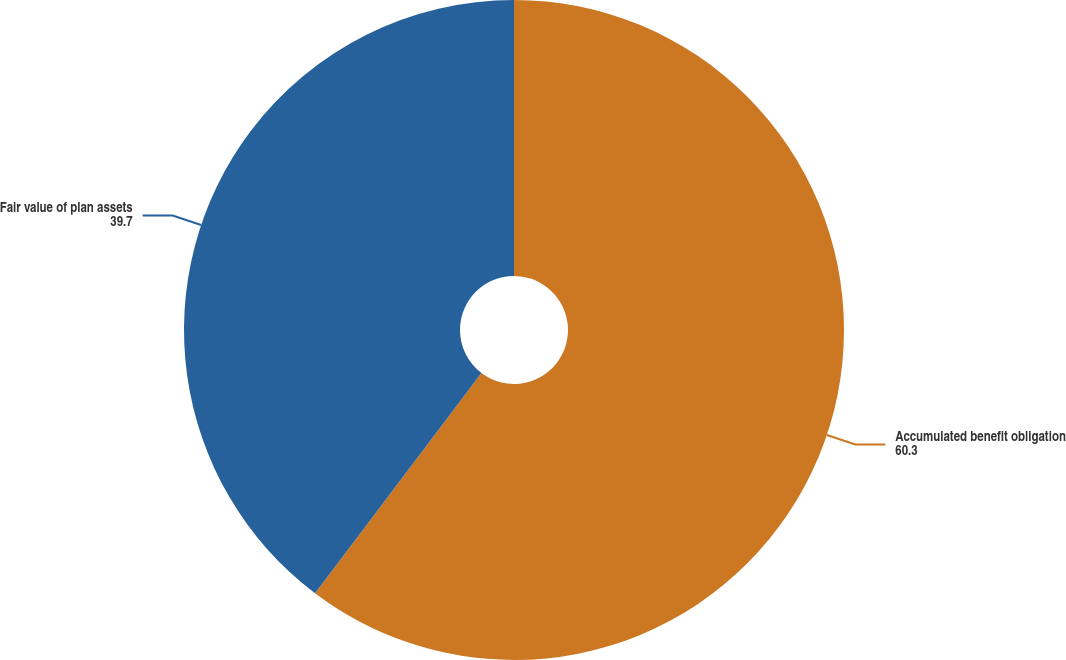<chart> <loc_0><loc_0><loc_500><loc_500><pie_chart><fcel>Accumulated benefit obligation<fcel>Fair value of plan assets<nl><fcel>60.3%<fcel>39.7%<nl></chart> 